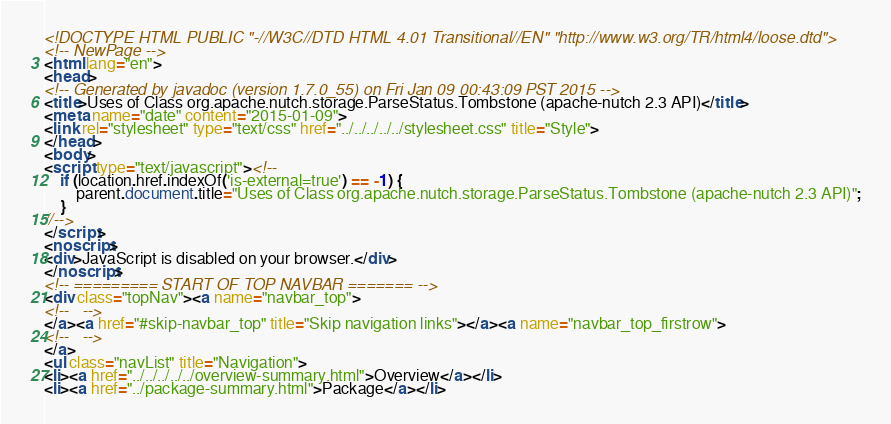<code> <loc_0><loc_0><loc_500><loc_500><_HTML_><!DOCTYPE HTML PUBLIC "-//W3C//DTD HTML 4.01 Transitional//EN" "http://www.w3.org/TR/html4/loose.dtd">
<!-- NewPage -->
<html lang="en">
<head>
<!-- Generated by javadoc (version 1.7.0_55) on Fri Jan 09 00:43:09 PST 2015 -->
<title>Uses of Class org.apache.nutch.storage.ParseStatus.Tombstone (apache-nutch 2.3 API)</title>
<meta name="date" content="2015-01-09">
<link rel="stylesheet" type="text/css" href="../../../../../stylesheet.css" title="Style">
</head>
<body>
<script type="text/javascript"><!--
    if (location.href.indexOf('is-external=true') == -1) {
        parent.document.title="Uses of Class org.apache.nutch.storage.ParseStatus.Tombstone (apache-nutch 2.3 API)";
    }
//-->
</script>
<noscript>
<div>JavaScript is disabled on your browser.</div>
</noscript>
<!-- ========= START OF TOP NAVBAR ======= -->
<div class="topNav"><a name="navbar_top">
<!--   -->
</a><a href="#skip-navbar_top" title="Skip navigation links"></a><a name="navbar_top_firstrow">
<!--   -->
</a>
<ul class="navList" title="Navigation">
<li><a href="../../../../../overview-summary.html">Overview</a></li>
<li><a href="../package-summary.html">Package</a></li></code> 